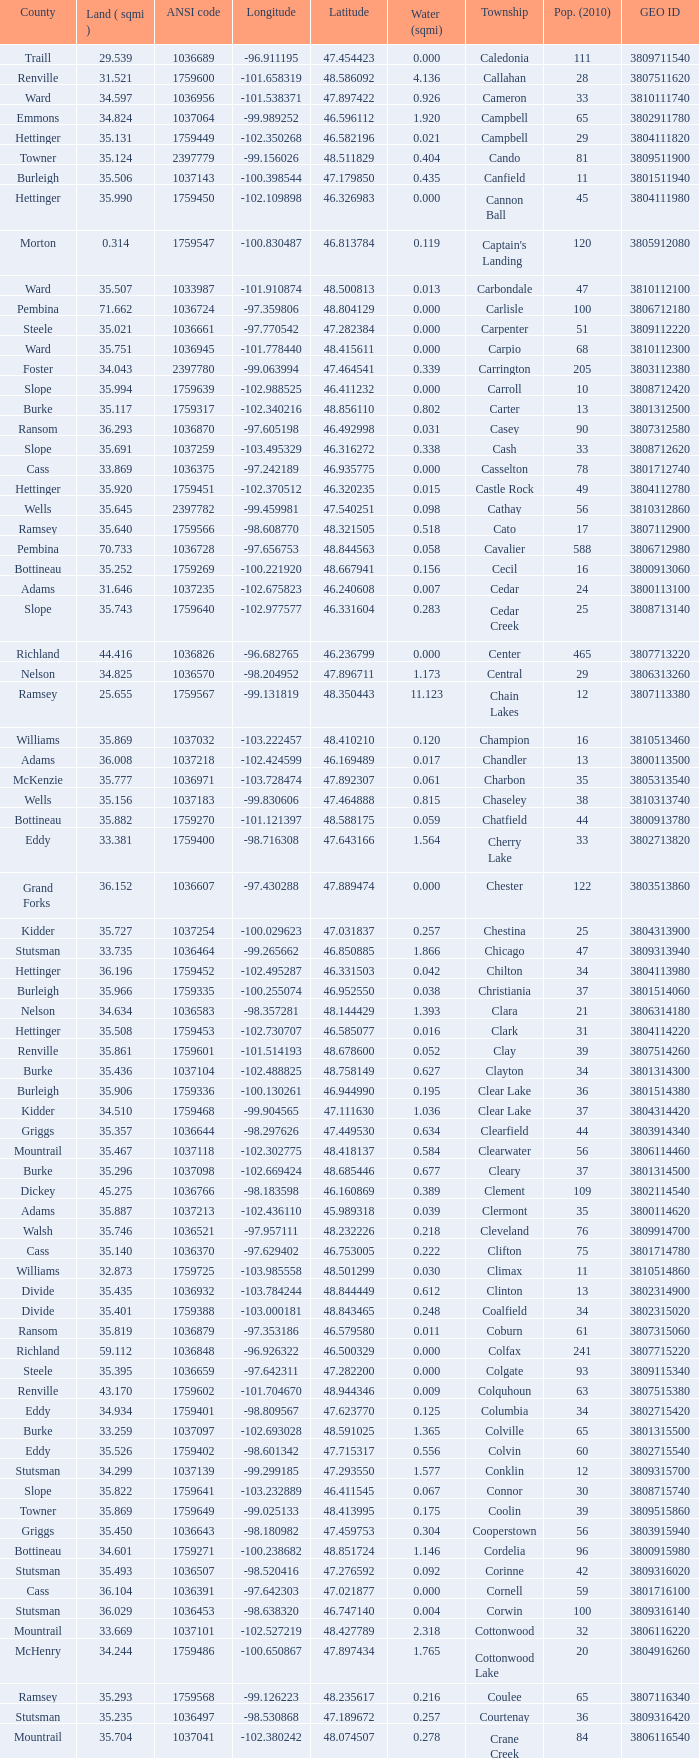What was the county with a longitude of -102.302775? Mountrail. 